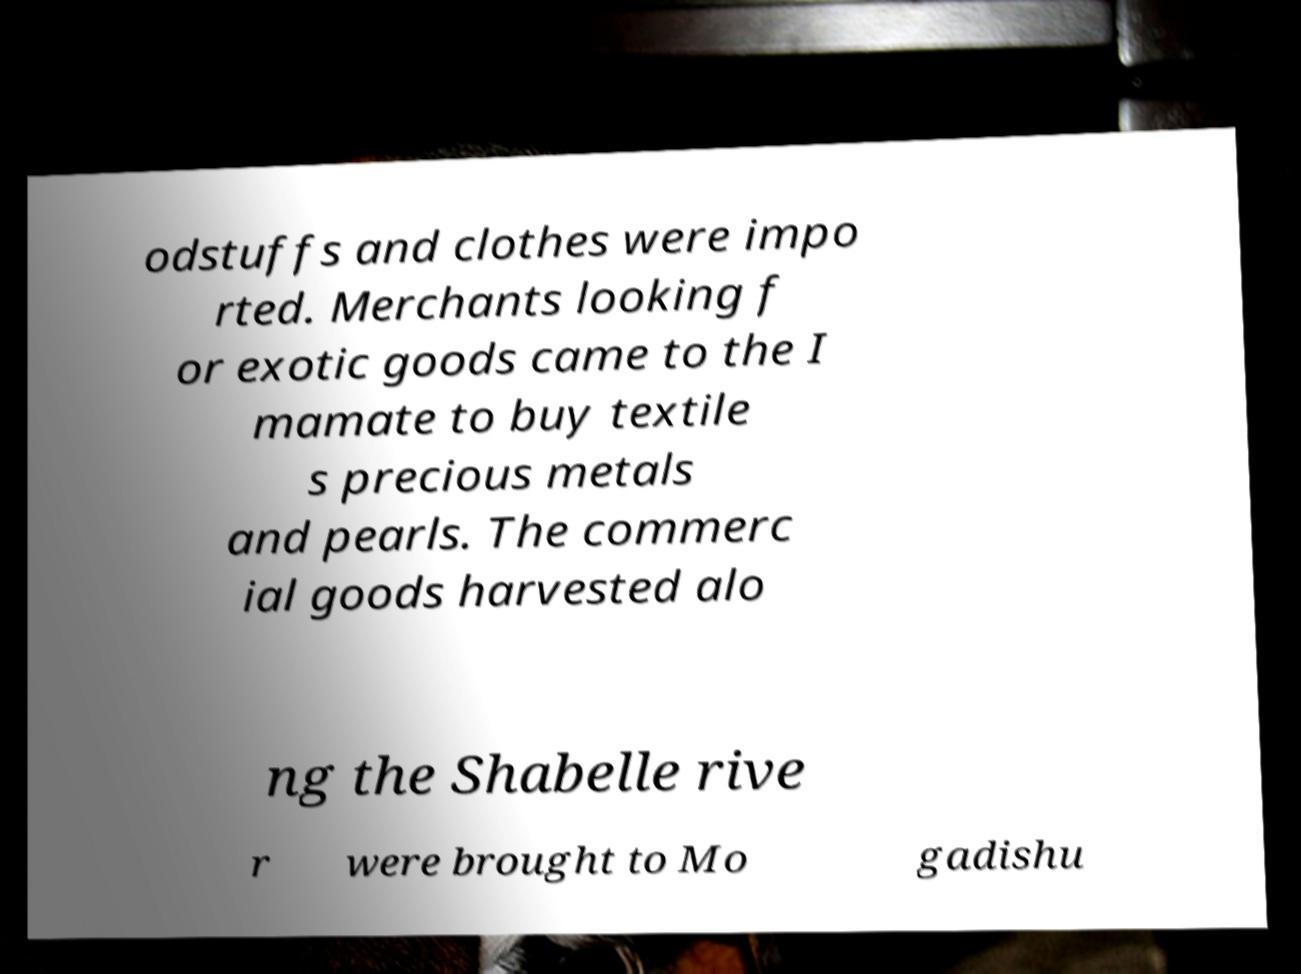Can you accurately transcribe the text from the provided image for me? odstuffs and clothes were impo rted. Merchants looking f or exotic goods came to the I mamate to buy textile s precious metals and pearls. The commerc ial goods harvested alo ng the Shabelle rive r were brought to Mo gadishu 